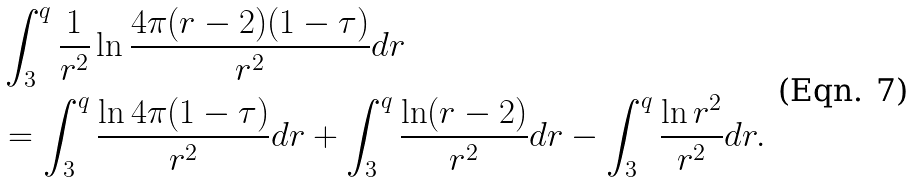Convert formula to latex. <formula><loc_0><loc_0><loc_500><loc_500>& \int _ { 3 } ^ { q } \frac { 1 } { r ^ { 2 } } \ln \frac { 4 \pi ( r - 2 ) ( 1 - \tau ) } { r ^ { 2 } } d r \\ & = \int _ { 3 } ^ { q } \frac { \ln 4 \pi ( 1 - \tau ) } { r ^ { 2 } } d r + \int _ { 3 } ^ { q } \frac { \ln ( r - 2 ) } { r ^ { 2 } } d r - \int _ { 3 } ^ { q } \frac { \ln r ^ { 2 } } { r ^ { 2 } } d r .</formula> 